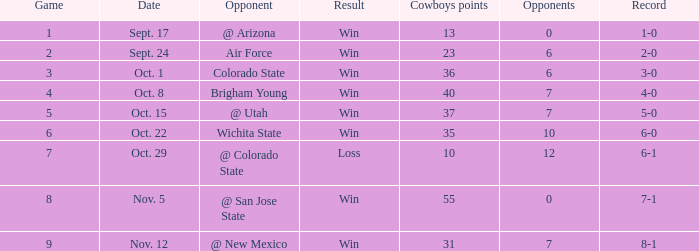When did the Cowboys score 13 points in 1966? Sept. 17. 